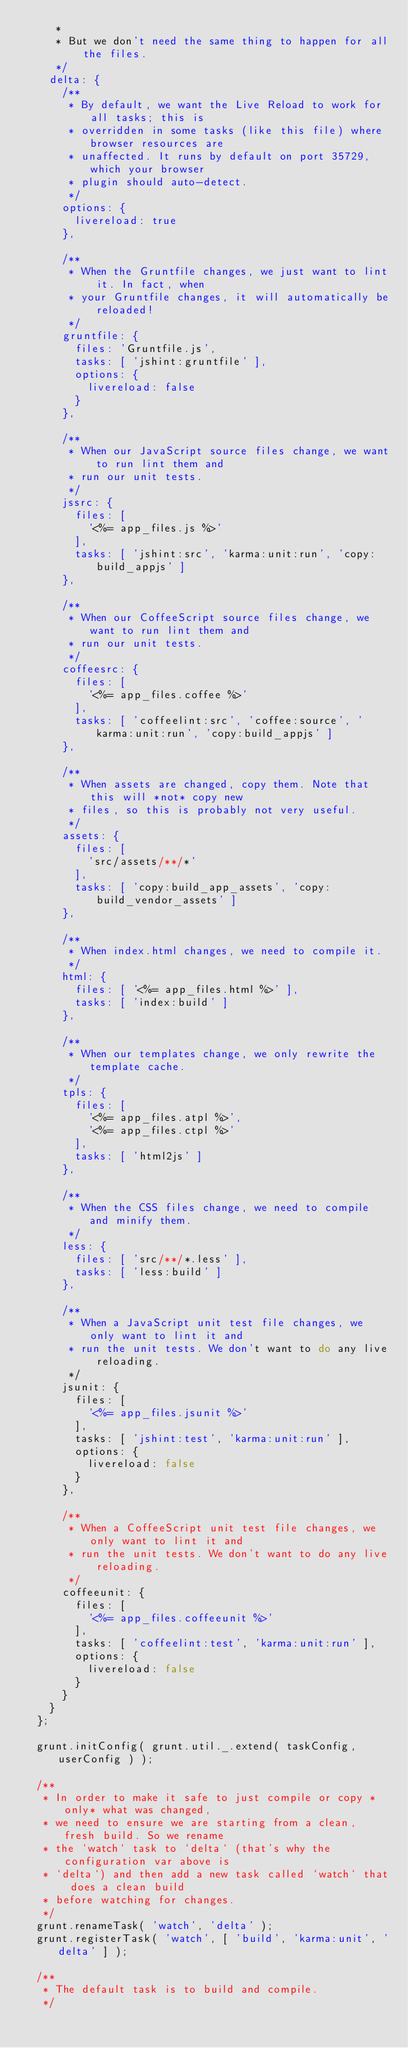Convert code to text. <code><loc_0><loc_0><loc_500><loc_500><_JavaScript_>     *
     * But we don't need the same thing to happen for all the files. 
     */
    delta: {
      /**
       * By default, we want the Live Reload to work for all tasks; this is
       * overridden in some tasks (like this file) where browser resources are
       * unaffected. It runs by default on port 35729, which your browser
       * plugin should auto-detect.
       */
      options: {
        livereload: true
      },

      /**
       * When the Gruntfile changes, we just want to lint it. In fact, when
       * your Gruntfile changes, it will automatically be reloaded!
       */
      gruntfile: {
        files: 'Gruntfile.js',
        tasks: [ 'jshint:gruntfile' ],
        options: {
          livereload: false
        }
      },

      /**
       * When our JavaScript source files change, we want to run lint them and
       * run our unit tests.
       */
      jssrc: {
        files: [ 
          '<%= app_files.js %>'
        ],
        tasks: [ 'jshint:src', 'karma:unit:run', 'copy:build_appjs' ]
      },

      /**
       * When our CoffeeScript source files change, we want to run lint them and
       * run our unit tests.
       */
      coffeesrc: {
        files: [ 
          '<%= app_files.coffee %>'
        ],
        tasks: [ 'coffeelint:src', 'coffee:source', 'karma:unit:run', 'copy:build_appjs' ]
      },

      /**
       * When assets are changed, copy them. Note that this will *not* copy new
       * files, so this is probably not very useful.
       */
      assets: {
        files: [ 
          'src/assets/**/*'
        ],
        tasks: [ 'copy:build_app_assets', 'copy:build_vendor_assets' ]
      },

      /**
       * When index.html changes, we need to compile it.
       */
      html: {
        files: [ '<%= app_files.html %>' ],
        tasks: [ 'index:build' ]
      },

      /**
       * When our templates change, we only rewrite the template cache.
       */
      tpls: {
        files: [ 
          '<%= app_files.atpl %>', 
          '<%= app_files.ctpl %>'
        ],
        tasks: [ 'html2js' ]
      },

      /**
       * When the CSS files change, we need to compile and minify them.
       */
      less: {
        files: [ 'src/**/*.less' ],
        tasks: [ 'less:build' ]
      },

      /**
       * When a JavaScript unit test file changes, we only want to lint it and
       * run the unit tests. We don't want to do any live reloading.
       */
      jsunit: {
        files: [
          '<%= app_files.jsunit %>'
        ],
        tasks: [ 'jshint:test', 'karma:unit:run' ],
        options: {
          livereload: false
        }
      },

      /**
       * When a CoffeeScript unit test file changes, we only want to lint it and
       * run the unit tests. We don't want to do any live reloading.
       */
      coffeeunit: {
        files: [
          '<%= app_files.coffeeunit %>'
        ],
        tasks: [ 'coffeelint:test', 'karma:unit:run' ],
        options: {
          livereload: false
        }
      }
    }
  };

  grunt.initConfig( grunt.util._.extend( taskConfig, userConfig ) );

  /**
   * In order to make it safe to just compile or copy *only* what was changed,
   * we need to ensure we are starting from a clean, fresh build. So we rename
   * the `watch` task to `delta` (that's why the configuration var above is
   * `delta`) and then add a new task called `watch` that does a clean build
   * before watching for changes.
   */
  grunt.renameTask( 'watch', 'delta' );
  grunt.registerTask( 'watch', [ 'build', 'karma:unit', 'delta' ] );

  /**
   * The default task is to build and compile.
   */</code> 